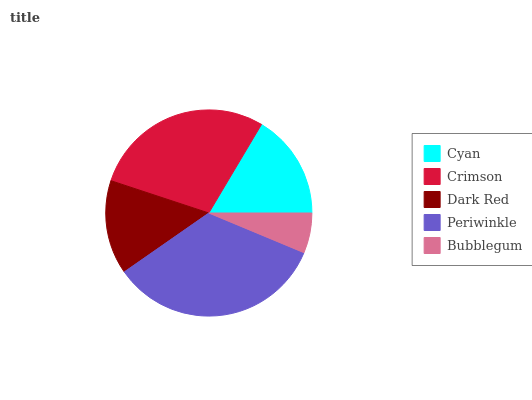Is Bubblegum the minimum?
Answer yes or no. Yes. Is Periwinkle the maximum?
Answer yes or no. Yes. Is Crimson the minimum?
Answer yes or no. No. Is Crimson the maximum?
Answer yes or no. No. Is Crimson greater than Cyan?
Answer yes or no. Yes. Is Cyan less than Crimson?
Answer yes or no. Yes. Is Cyan greater than Crimson?
Answer yes or no. No. Is Crimson less than Cyan?
Answer yes or no. No. Is Cyan the high median?
Answer yes or no. Yes. Is Cyan the low median?
Answer yes or no. Yes. Is Dark Red the high median?
Answer yes or no. No. Is Periwinkle the low median?
Answer yes or no. No. 